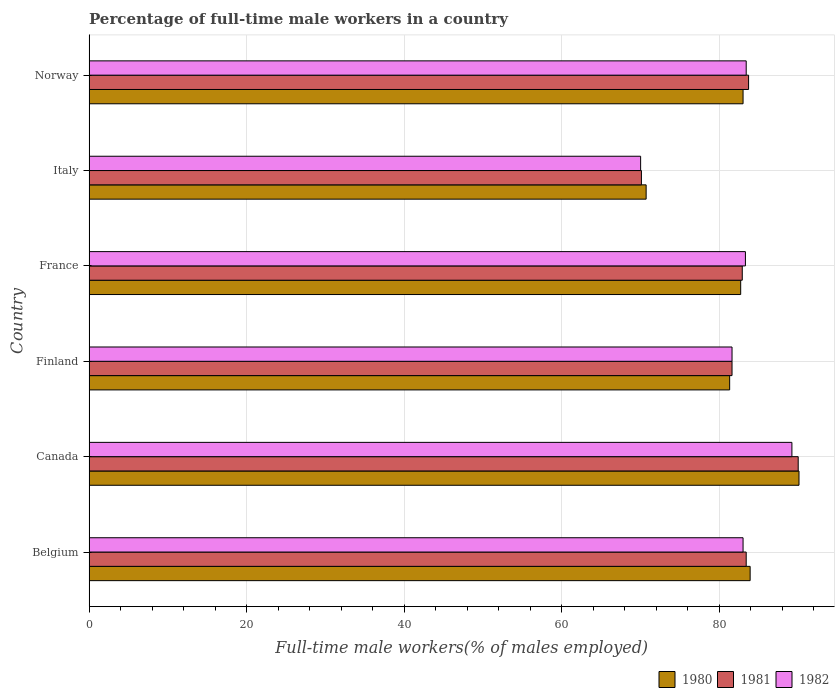How many different coloured bars are there?
Give a very brief answer. 3. How many bars are there on the 3rd tick from the bottom?
Keep it short and to the point. 3. What is the percentage of full-time male workers in 1982 in Norway?
Make the answer very short. 83.4. Across all countries, what is the maximum percentage of full-time male workers in 1980?
Ensure brevity in your answer.  90.1. Across all countries, what is the minimum percentage of full-time male workers in 1980?
Your response must be concise. 70.7. In which country was the percentage of full-time male workers in 1980 maximum?
Keep it short and to the point. Canada. What is the total percentage of full-time male workers in 1980 in the graph?
Keep it short and to the point. 491.7. What is the difference between the percentage of full-time male workers in 1981 in Canada and that in France?
Your response must be concise. 7.1. What is the difference between the percentage of full-time male workers in 1980 in France and the percentage of full-time male workers in 1981 in Belgium?
Offer a terse response. -0.7. What is the average percentage of full-time male workers in 1980 per country?
Ensure brevity in your answer.  81.95. What is the difference between the percentage of full-time male workers in 1981 and percentage of full-time male workers in 1982 in France?
Your answer should be very brief. -0.4. What is the ratio of the percentage of full-time male workers in 1980 in Belgium to that in Canada?
Offer a very short reply. 0.93. Is the percentage of full-time male workers in 1981 in Belgium less than that in Finland?
Your answer should be compact. No. What is the difference between the highest and the second highest percentage of full-time male workers in 1980?
Keep it short and to the point. 6.2. What is the difference between the highest and the lowest percentage of full-time male workers in 1982?
Make the answer very short. 19.2. In how many countries, is the percentage of full-time male workers in 1982 greater than the average percentage of full-time male workers in 1982 taken over all countries?
Keep it short and to the point. 4. Is the sum of the percentage of full-time male workers in 1980 in Belgium and Italy greater than the maximum percentage of full-time male workers in 1982 across all countries?
Provide a short and direct response. Yes. What does the 3rd bar from the top in Norway represents?
Keep it short and to the point. 1980. Is it the case that in every country, the sum of the percentage of full-time male workers in 1981 and percentage of full-time male workers in 1982 is greater than the percentage of full-time male workers in 1980?
Your answer should be very brief. Yes. How many bars are there?
Make the answer very short. 18. Are all the bars in the graph horizontal?
Provide a succinct answer. Yes. What is the difference between two consecutive major ticks on the X-axis?
Your answer should be compact. 20. Are the values on the major ticks of X-axis written in scientific E-notation?
Offer a terse response. No. Does the graph contain grids?
Provide a short and direct response. Yes. Where does the legend appear in the graph?
Give a very brief answer. Bottom right. What is the title of the graph?
Provide a short and direct response. Percentage of full-time male workers in a country. What is the label or title of the X-axis?
Keep it short and to the point. Full-time male workers(% of males employed). What is the label or title of the Y-axis?
Your response must be concise. Country. What is the Full-time male workers(% of males employed) in 1980 in Belgium?
Make the answer very short. 83.9. What is the Full-time male workers(% of males employed) in 1981 in Belgium?
Provide a short and direct response. 83.4. What is the Full-time male workers(% of males employed) in 1980 in Canada?
Your answer should be very brief. 90.1. What is the Full-time male workers(% of males employed) in 1981 in Canada?
Provide a short and direct response. 90. What is the Full-time male workers(% of males employed) of 1982 in Canada?
Provide a short and direct response. 89.2. What is the Full-time male workers(% of males employed) of 1980 in Finland?
Keep it short and to the point. 81.3. What is the Full-time male workers(% of males employed) in 1981 in Finland?
Make the answer very short. 81.6. What is the Full-time male workers(% of males employed) of 1982 in Finland?
Keep it short and to the point. 81.6. What is the Full-time male workers(% of males employed) of 1980 in France?
Make the answer very short. 82.7. What is the Full-time male workers(% of males employed) in 1981 in France?
Ensure brevity in your answer.  82.9. What is the Full-time male workers(% of males employed) of 1982 in France?
Keep it short and to the point. 83.3. What is the Full-time male workers(% of males employed) in 1980 in Italy?
Keep it short and to the point. 70.7. What is the Full-time male workers(% of males employed) in 1981 in Italy?
Provide a succinct answer. 70.1. What is the Full-time male workers(% of males employed) in 1980 in Norway?
Your answer should be very brief. 83. What is the Full-time male workers(% of males employed) of 1981 in Norway?
Offer a very short reply. 83.7. What is the Full-time male workers(% of males employed) of 1982 in Norway?
Your answer should be very brief. 83.4. Across all countries, what is the maximum Full-time male workers(% of males employed) of 1980?
Ensure brevity in your answer.  90.1. Across all countries, what is the maximum Full-time male workers(% of males employed) of 1982?
Your response must be concise. 89.2. Across all countries, what is the minimum Full-time male workers(% of males employed) of 1980?
Make the answer very short. 70.7. Across all countries, what is the minimum Full-time male workers(% of males employed) in 1981?
Make the answer very short. 70.1. Across all countries, what is the minimum Full-time male workers(% of males employed) in 1982?
Offer a terse response. 70. What is the total Full-time male workers(% of males employed) in 1980 in the graph?
Your answer should be very brief. 491.7. What is the total Full-time male workers(% of males employed) of 1981 in the graph?
Keep it short and to the point. 491.7. What is the total Full-time male workers(% of males employed) of 1982 in the graph?
Your answer should be compact. 490.5. What is the difference between the Full-time male workers(% of males employed) in 1981 in Belgium and that in Canada?
Offer a very short reply. -6.6. What is the difference between the Full-time male workers(% of males employed) of 1982 in Belgium and that in Finland?
Your answer should be very brief. 1.4. What is the difference between the Full-time male workers(% of males employed) in 1981 in Belgium and that in France?
Offer a very short reply. 0.5. What is the difference between the Full-time male workers(% of males employed) of 1982 in Belgium and that in France?
Provide a short and direct response. -0.3. What is the difference between the Full-time male workers(% of males employed) in 1980 in Belgium and that in Italy?
Your answer should be very brief. 13.2. What is the difference between the Full-time male workers(% of males employed) of 1980 in Belgium and that in Norway?
Provide a succinct answer. 0.9. What is the difference between the Full-time male workers(% of males employed) of 1981 in Belgium and that in Norway?
Your answer should be compact. -0.3. What is the difference between the Full-time male workers(% of males employed) of 1982 in Belgium and that in Norway?
Your answer should be compact. -0.4. What is the difference between the Full-time male workers(% of males employed) of 1980 in Canada and that in Finland?
Make the answer very short. 8.8. What is the difference between the Full-time male workers(% of males employed) of 1981 in Canada and that in Finland?
Make the answer very short. 8.4. What is the difference between the Full-time male workers(% of males employed) in 1980 in Canada and that in France?
Keep it short and to the point. 7.4. What is the difference between the Full-time male workers(% of males employed) in 1980 in Canada and that in Italy?
Your response must be concise. 19.4. What is the difference between the Full-time male workers(% of males employed) in 1982 in Canada and that in Italy?
Keep it short and to the point. 19.2. What is the difference between the Full-time male workers(% of males employed) of 1981 in Canada and that in Norway?
Offer a terse response. 6.3. What is the difference between the Full-time male workers(% of males employed) in 1982 in Canada and that in Norway?
Ensure brevity in your answer.  5.8. What is the difference between the Full-time male workers(% of males employed) in 1980 in Finland and that in France?
Give a very brief answer. -1.4. What is the difference between the Full-time male workers(% of males employed) of 1980 in Finland and that in Italy?
Make the answer very short. 10.6. What is the difference between the Full-time male workers(% of males employed) of 1981 in Finland and that in Italy?
Offer a terse response. 11.5. What is the difference between the Full-time male workers(% of males employed) in 1982 in Finland and that in Italy?
Your response must be concise. 11.6. What is the difference between the Full-time male workers(% of males employed) in 1980 in Finland and that in Norway?
Offer a very short reply. -1.7. What is the difference between the Full-time male workers(% of males employed) of 1982 in Finland and that in Norway?
Give a very brief answer. -1.8. What is the difference between the Full-time male workers(% of males employed) in 1980 in France and that in Italy?
Offer a very short reply. 12. What is the difference between the Full-time male workers(% of males employed) of 1981 in France and that in Italy?
Your response must be concise. 12.8. What is the difference between the Full-time male workers(% of males employed) of 1980 in France and that in Norway?
Your answer should be very brief. -0.3. What is the difference between the Full-time male workers(% of males employed) of 1982 in France and that in Norway?
Ensure brevity in your answer.  -0.1. What is the difference between the Full-time male workers(% of males employed) of 1980 in Italy and that in Norway?
Ensure brevity in your answer.  -12.3. What is the difference between the Full-time male workers(% of males employed) of 1982 in Italy and that in Norway?
Make the answer very short. -13.4. What is the difference between the Full-time male workers(% of males employed) of 1980 in Belgium and the Full-time male workers(% of males employed) of 1981 in Canada?
Provide a short and direct response. -6.1. What is the difference between the Full-time male workers(% of males employed) of 1981 in Belgium and the Full-time male workers(% of males employed) of 1982 in Canada?
Keep it short and to the point. -5.8. What is the difference between the Full-time male workers(% of males employed) of 1980 in Belgium and the Full-time male workers(% of males employed) of 1982 in Finland?
Keep it short and to the point. 2.3. What is the difference between the Full-time male workers(% of males employed) in 1981 in Belgium and the Full-time male workers(% of males employed) in 1982 in Italy?
Provide a short and direct response. 13.4. What is the difference between the Full-time male workers(% of males employed) of 1980 in Belgium and the Full-time male workers(% of males employed) of 1981 in Norway?
Offer a terse response. 0.2. What is the difference between the Full-time male workers(% of males employed) in 1980 in Belgium and the Full-time male workers(% of males employed) in 1982 in Norway?
Keep it short and to the point. 0.5. What is the difference between the Full-time male workers(% of males employed) in 1981 in Belgium and the Full-time male workers(% of males employed) in 1982 in Norway?
Make the answer very short. 0. What is the difference between the Full-time male workers(% of males employed) of 1980 in Canada and the Full-time male workers(% of males employed) of 1981 in Finland?
Provide a succinct answer. 8.5. What is the difference between the Full-time male workers(% of males employed) in 1980 in Canada and the Full-time male workers(% of males employed) in 1981 in France?
Provide a succinct answer. 7.2. What is the difference between the Full-time male workers(% of males employed) of 1980 in Canada and the Full-time male workers(% of males employed) of 1982 in France?
Your response must be concise. 6.8. What is the difference between the Full-time male workers(% of males employed) in 1981 in Canada and the Full-time male workers(% of males employed) in 1982 in France?
Provide a short and direct response. 6.7. What is the difference between the Full-time male workers(% of males employed) in 1980 in Canada and the Full-time male workers(% of males employed) in 1981 in Italy?
Offer a terse response. 20. What is the difference between the Full-time male workers(% of males employed) of 1980 in Canada and the Full-time male workers(% of males employed) of 1982 in Italy?
Provide a succinct answer. 20.1. What is the difference between the Full-time male workers(% of males employed) in 1981 in Canada and the Full-time male workers(% of males employed) in 1982 in Italy?
Provide a succinct answer. 20. What is the difference between the Full-time male workers(% of males employed) in 1980 in Canada and the Full-time male workers(% of males employed) in 1981 in Norway?
Give a very brief answer. 6.4. What is the difference between the Full-time male workers(% of males employed) of 1981 in Canada and the Full-time male workers(% of males employed) of 1982 in Norway?
Give a very brief answer. 6.6. What is the difference between the Full-time male workers(% of males employed) in 1980 in Finland and the Full-time male workers(% of males employed) in 1981 in France?
Your answer should be compact. -1.6. What is the difference between the Full-time male workers(% of males employed) in 1981 in Finland and the Full-time male workers(% of males employed) in 1982 in France?
Your answer should be compact. -1.7. What is the difference between the Full-time male workers(% of males employed) of 1980 in Finland and the Full-time male workers(% of males employed) of 1981 in Norway?
Keep it short and to the point. -2.4. What is the difference between the Full-time male workers(% of males employed) of 1981 in Finland and the Full-time male workers(% of males employed) of 1982 in Norway?
Give a very brief answer. -1.8. What is the difference between the Full-time male workers(% of males employed) of 1980 in France and the Full-time male workers(% of males employed) of 1981 in Italy?
Offer a very short reply. 12.6. What is the difference between the Full-time male workers(% of males employed) of 1980 in France and the Full-time male workers(% of males employed) of 1982 in Italy?
Ensure brevity in your answer.  12.7. What is the difference between the Full-time male workers(% of males employed) in 1980 in France and the Full-time male workers(% of males employed) in 1981 in Norway?
Keep it short and to the point. -1. What is the difference between the Full-time male workers(% of males employed) of 1980 in France and the Full-time male workers(% of males employed) of 1982 in Norway?
Offer a terse response. -0.7. What is the difference between the Full-time male workers(% of males employed) of 1980 in Italy and the Full-time male workers(% of males employed) of 1982 in Norway?
Offer a terse response. -12.7. What is the average Full-time male workers(% of males employed) in 1980 per country?
Your response must be concise. 81.95. What is the average Full-time male workers(% of males employed) of 1981 per country?
Provide a succinct answer. 81.95. What is the average Full-time male workers(% of males employed) of 1982 per country?
Provide a succinct answer. 81.75. What is the difference between the Full-time male workers(% of males employed) in 1980 and Full-time male workers(% of males employed) in 1981 in Canada?
Your answer should be very brief. 0.1. What is the difference between the Full-time male workers(% of males employed) of 1980 and Full-time male workers(% of males employed) of 1981 in Finland?
Offer a very short reply. -0.3. What is the difference between the Full-time male workers(% of males employed) in 1981 and Full-time male workers(% of males employed) in 1982 in Finland?
Offer a very short reply. 0. What is the difference between the Full-time male workers(% of males employed) in 1980 and Full-time male workers(% of males employed) in 1982 in France?
Offer a terse response. -0.6. What is the difference between the Full-time male workers(% of males employed) in 1981 and Full-time male workers(% of males employed) in 1982 in Italy?
Give a very brief answer. 0.1. What is the difference between the Full-time male workers(% of males employed) in 1981 and Full-time male workers(% of males employed) in 1982 in Norway?
Provide a succinct answer. 0.3. What is the ratio of the Full-time male workers(% of males employed) in 1980 in Belgium to that in Canada?
Your response must be concise. 0.93. What is the ratio of the Full-time male workers(% of males employed) in 1981 in Belgium to that in Canada?
Provide a succinct answer. 0.93. What is the ratio of the Full-time male workers(% of males employed) of 1982 in Belgium to that in Canada?
Keep it short and to the point. 0.93. What is the ratio of the Full-time male workers(% of males employed) in 1980 in Belgium to that in Finland?
Provide a short and direct response. 1.03. What is the ratio of the Full-time male workers(% of males employed) in 1981 in Belgium to that in Finland?
Keep it short and to the point. 1.02. What is the ratio of the Full-time male workers(% of males employed) of 1982 in Belgium to that in Finland?
Make the answer very short. 1.02. What is the ratio of the Full-time male workers(% of males employed) of 1980 in Belgium to that in France?
Your answer should be very brief. 1.01. What is the ratio of the Full-time male workers(% of males employed) in 1982 in Belgium to that in France?
Your answer should be compact. 1. What is the ratio of the Full-time male workers(% of males employed) of 1980 in Belgium to that in Italy?
Offer a terse response. 1.19. What is the ratio of the Full-time male workers(% of males employed) of 1981 in Belgium to that in Italy?
Your response must be concise. 1.19. What is the ratio of the Full-time male workers(% of males employed) in 1982 in Belgium to that in Italy?
Make the answer very short. 1.19. What is the ratio of the Full-time male workers(% of males employed) of 1980 in Belgium to that in Norway?
Your response must be concise. 1.01. What is the ratio of the Full-time male workers(% of males employed) in 1980 in Canada to that in Finland?
Give a very brief answer. 1.11. What is the ratio of the Full-time male workers(% of males employed) of 1981 in Canada to that in Finland?
Your answer should be compact. 1.1. What is the ratio of the Full-time male workers(% of males employed) in 1982 in Canada to that in Finland?
Offer a very short reply. 1.09. What is the ratio of the Full-time male workers(% of males employed) of 1980 in Canada to that in France?
Keep it short and to the point. 1.09. What is the ratio of the Full-time male workers(% of males employed) in 1981 in Canada to that in France?
Provide a short and direct response. 1.09. What is the ratio of the Full-time male workers(% of males employed) in 1982 in Canada to that in France?
Provide a short and direct response. 1.07. What is the ratio of the Full-time male workers(% of males employed) in 1980 in Canada to that in Italy?
Ensure brevity in your answer.  1.27. What is the ratio of the Full-time male workers(% of males employed) of 1981 in Canada to that in Italy?
Your answer should be compact. 1.28. What is the ratio of the Full-time male workers(% of males employed) of 1982 in Canada to that in Italy?
Your answer should be very brief. 1.27. What is the ratio of the Full-time male workers(% of males employed) of 1980 in Canada to that in Norway?
Make the answer very short. 1.09. What is the ratio of the Full-time male workers(% of males employed) in 1981 in Canada to that in Norway?
Keep it short and to the point. 1.08. What is the ratio of the Full-time male workers(% of males employed) of 1982 in Canada to that in Norway?
Give a very brief answer. 1.07. What is the ratio of the Full-time male workers(% of males employed) in 1980 in Finland to that in France?
Provide a short and direct response. 0.98. What is the ratio of the Full-time male workers(% of males employed) in 1981 in Finland to that in France?
Your answer should be compact. 0.98. What is the ratio of the Full-time male workers(% of males employed) in 1982 in Finland to that in France?
Ensure brevity in your answer.  0.98. What is the ratio of the Full-time male workers(% of males employed) of 1980 in Finland to that in Italy?
Offer a very short reply. 1.15. What is the ratio of the Full-time male workers(% of males employed) of 1981 in Finland to that in Italy?
Give a very brief answer. 1.16. What is the ratio of the Full-time male workers(% of males employed) in 1982 in Finland to that in Italy?
Make the answer very short. 1.17. What is the ratio of the Full-time male workers(% of males employed) of 1980 in Finland to that in Norway?
Provide a short and direct response. 0.98. What is the ratio of the Full-time male workers(% of males employed) of 1981 in Finland to that in Norway?
Ensure brevity in your answer.  0.97. What is the ratio of the Full-time male workers(% of males employed) of 1982 in Finland to that in Norway?
Your answer should be compact. 0.98. What is the ratio of the Full-time male workers(% of males employed) of 1980 in France to that in Italy?
Offer a very short reply. 1.17. What is the ratio of the Full-time male workers(% of males employed) of 1981 in France to that in Italy?
Ensure brevity in your answer.  1.18. What is the ratio of the Full-time male workers(% of males employed) in 1982 in France to that in Italy?
Offer a very short reply. 1.19. What is the ratio of the Full-time male workers(% of males employed) in 1980 in Italy to that in Norway?
Offer a terse response. 0.85. What is the ratio of the Full-time male workers(% of males employed) in 1981 in Italy to that in Norway?
Keep it short and to the point. 0.84. What is the ratio of the Full-time male workers(% of males employed) in 1982 in Italy to that in Norway?
Make the answer very short. 0.84. What is the difference between the highest and the second highest Full-time male workers(% of males employed) of 1980?
Offer a very short reply. 6.2. What is the difference between the highest and the second highest Full-time male workers(% of males employed) of 1982?
Offer a terse response. 5.8. 